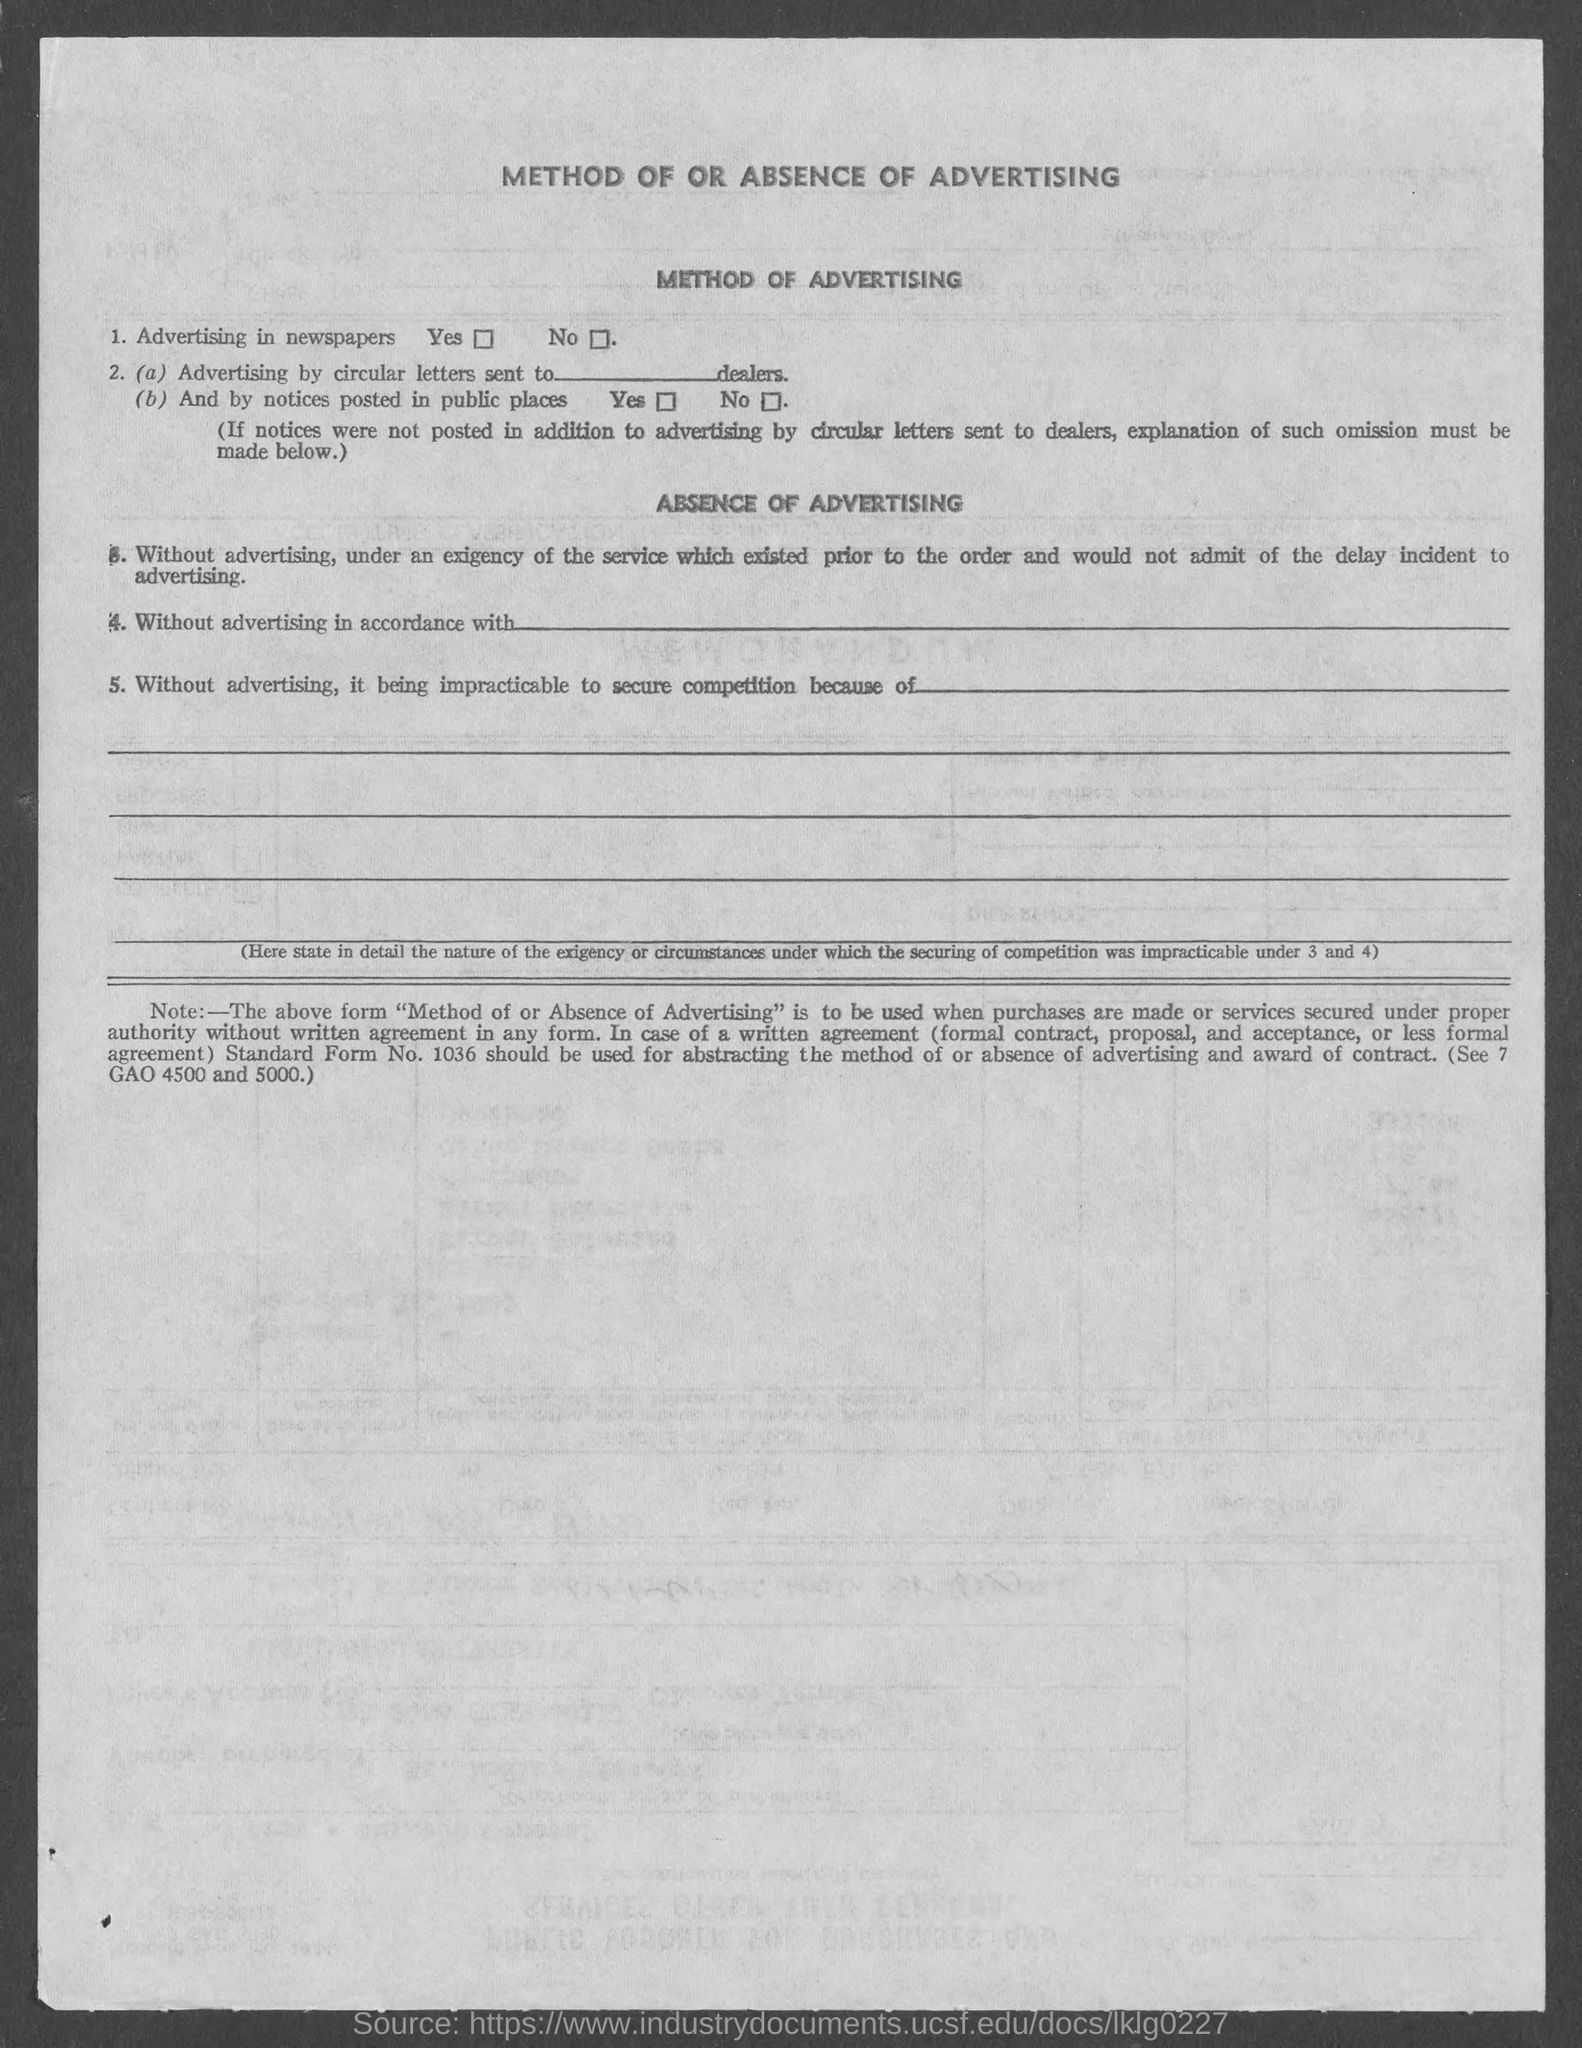What is the heading of the page?
Your response must be concise. Method of or Absence of Advertising. 